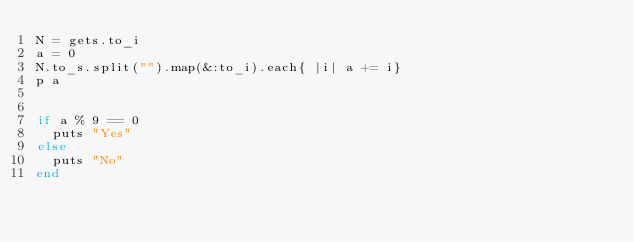Convert code to text. <code><loc_0><loc_0><loc_500><loc_500><_Ruby_>N = gets.to_i
a = 0
N.to_s.split("").map(&:to_i).each{ |i| a += i}
p a


if a % 9 == 0
  puts "Yes"
else
  puts "No"
end
</code> 